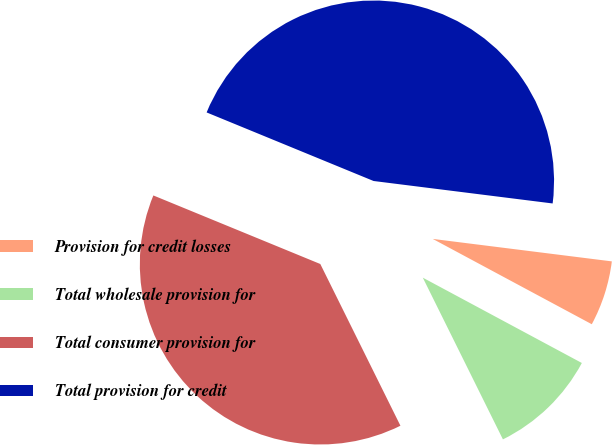Convert chart to OTSL. <chart><loc_0><loc_0><loc_500><loc_500><pie_chart><fcel>Provision for credit losses<fcel>Total wholesale provision for<fcel>Total consumer provision for<fcel>Total provision for credit<nl><fcel>5.85%<fcel>9.84%<fcel>38.52%<fcel>45.78%<nl></chart> 